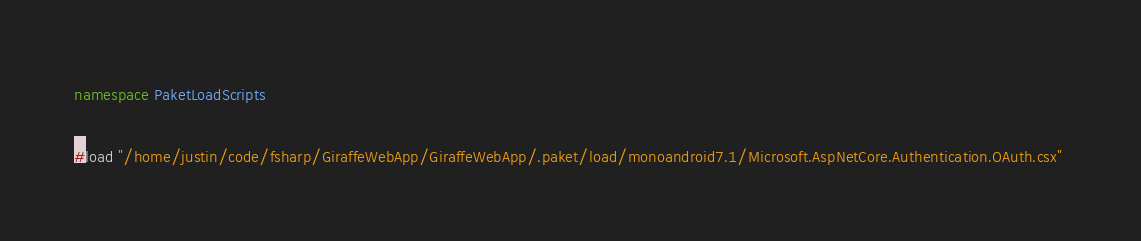Convert code to text. <code><loc_0><loc_0><loc_500><loc_500><_C#_>namespace PaketLoadScripts

#load "/home/justin/code/fsharp/GiraffeWebApp/GiraffeWebApp/.paket/load/monoandroid7.1/Microsoft.AspNetCore.Authentication.OAuth.csx" </code> 